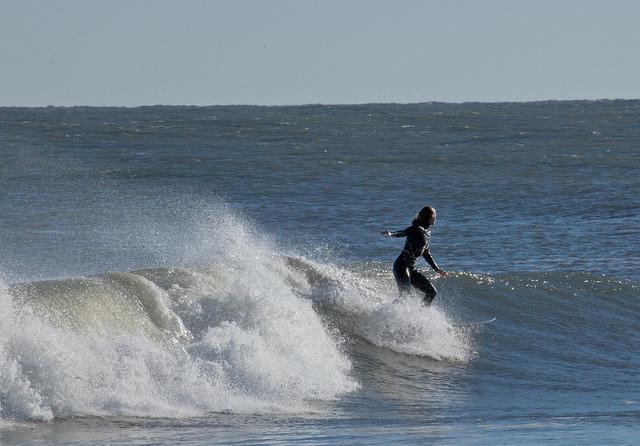How many people can this boat seat?
Give a very brief answer. 0. 